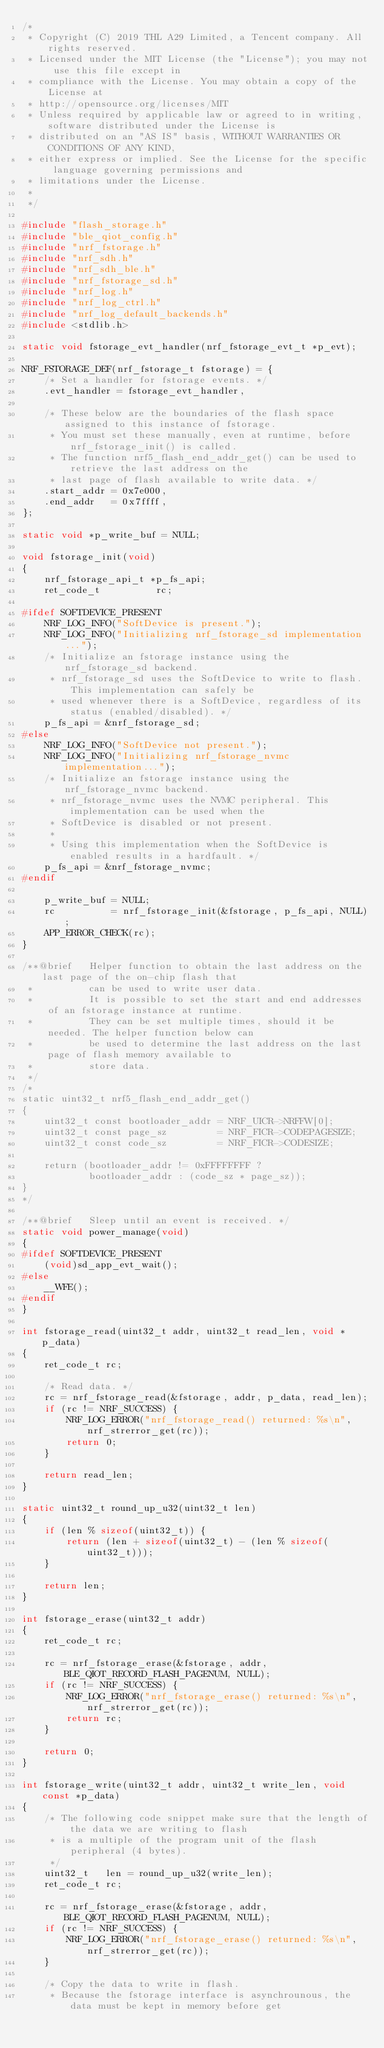<code> <loc_0><loc_0><loc_500><loc_500><_C_>/*
 * Copyright (C) 2019 THL A29 Limited, a Tencent company. All rights reserved.
 * Licensed under the MIT License (the "License"); you may not use this file except in
 * compliance with the License. You may obtain a copy of the License at
 * http://opensource.org/licenses/MIT
 * Unless required by applicable law or agreed to in writing, software distributed under the License is
 * distributed on an "AS IS" basis, WITHOUT WARRANTIES OR CONDITIONS OF ANY KIND,
 * either express or implied. See the License for the specific language governing permissions and
 * limitations under the License.
 *
 */

#include "flash_storage.h"
#include "ble_qiot_config.h"
#include "nrf_fstorage.h"
#include "nrf_sdh.h"
#include "nrf_sdh_ble.h"
#include "nrf_fstorage_sd.h"
#include "nrf_log.h"
#include "nrf_log_ctrl.h"
#include "nrf_log_default_backends.h"
#include <stdlib.h>

static void fstorage_evt_handler(nrf_fstorage_evt_t *p_evt);

NRF_FSTORAGE_DEF(nrf_fstorage_t fstorage) = {
    /* Set a handler for fstorage events. */
    .evt_handler = fstorage_evt_handler,

    /* These below are the boundaries of the flash space assigned to this instance of fstorage.
     * You must set these manually, even at runtime, before nrf_fstorage_init() is called.
     * The function nrf5_flash_end_addr_get() can be used to retrieve the last address on the
     * last page of flash available to write data. */
    .start_addr = 0x7e000,
    .end_addr   = 0x7ffff,
};

static void *p_write_buf = NULL;

void fstorage_init(void)
{
    nrf_fstorage_api_t *p_fs_api;
    ret_code_t          rc;

#ifdef SOFTDEVICE_PRESENT
    NRF_LOG_INFO("SoftDevice is present.");
    NRF_LOG_INFO("Initializing nrf_fstorage_sd implementation...");
    /* Initialize an fstorage instance using the nrf_fstorage_sd backend.
     * nrf_fstorage_sd uses the SoftDevice to write to flash. This implementation can safely be
     * used whenever there is a SoftDevice, regardless of its status (enabled/disabled). */
    p_fs_api = &nrf_fstorage_sd;
#else
    NRF_LOG_INFO("SoftDevice not present.");
    NRF_LOG_INFO("Initializing nrf_fstorage_nvmc implementation...");
    /* Initialize an fstorage instance using the nrf_fstorage_nvmc backend.
     * nrf_fstorage_nvmc uses the NVMC peripheral. This implementation can be used when the
     * SoftDevice is disabled or not present.
     *
     * Using this implementation when the SoftDevice is enabled results in a hardfault. */
    p_fs_api = &nrf_fstorage_nvmc;
#endif

    p_write_buf = NULL;
    rc          = nrf_fstorage_init(&fstorage, p_fs_api, NULL);
    APP_ERROR_CHECK(rc);
}

/**@brief   Helper function to obtain the last address on the last page of the on-chip flash that
 *          can be used to write user data.
 *          It is possible to set the start and end addresses of an fstorage instance at runtime.
 *          They can be set multiple times, should it be needed. The helper function below can
 *          be used to determine the last address on the last page of flash memory available to
 *          store data.
 */
/*
static uint32_t nrf5_flash_end_addr_get()
{
    uint32_t const bootloader_addr = NRF_UICR->NRFFW[0];
    uint32_t const page_sz         = NRF_FICR->CODEPAGESIZE;
    uint32_t const code_sz         = NRF_FICR->CODESIZE;

    return (bootloader_addr != 0xFFFFFFFF ?
            bootloader_addr : (code_sz * page_sz));
}
*/

/**@brief   Sleep until an event is received. */
static void power_manage(void)
{
#ifdef SOFTDEVICE_PRESENT
    (void)sd_app_evt_wait();
#else
    __WFE();
#endif
}

int fstorage_read(uint32_t addr, uint32_t read_len, void *p_data)
{
    ret_code_t rc;

    /* Read data. */
    rc = nrf_fstorage_read(&fstorage, addr, p_data, read_len);
    if (rc != NRF_SUCCESS) {
        NRF_LOG_ERROR("nrf_fstorage_read() returned: %s\n", nrf_strerror_get(rc));
        return 0;
    }

    return read_len;
}

static uint32_t round_up_u32(uint32_t len)
{
    if (len % sizeof(uint32_t)) {
        return (len + sizeof(uint32_t) - (len % sizeof(uint32_t)));
    }

    return len;
}

int fstorage_erase(uint32_t addr)
{
    ret_code_t rc;

    rc = nrf_fstorage_erase(&fstorage, addr, BLE_QIOT_RECORD_FLASH_PAGENUM, NULL);
    if (rc != NRF_SUCCESS) {
        NRF_LOG_ERROR("nrf_fstorage_erase() returned: %s\n", nrf_strerror_get(rc));
        return rc;
    }

    return 0;
}

int fstorage_write(uint32_t addr, uint32_t write_len, void const *p_data)
{
    /* The following code snippet make sure that the length of the data we are writing to flash
     * is a multiple of the program unit of the flash peripheral (4 bytes).
     */
    uint32_t   len = round_up_u32(write_len);
    ret_code_t rc;

    rc = nrf_fstorage_erase(&fstorage, addr, BLE_QIOT_RECORD_FLASH_PAGENUM, NULL);
    if (rc != NRF_SUCCESS) {
        NRF_LOG_ERROR("nrf_fstorage_erase() returned: %s\n", nrf_strerror_get(rc));
    }

    /* Copy the data to write in flash.
     * Because the fstorage interface is asynchrounous, the data must be kept in memory before get</code> 